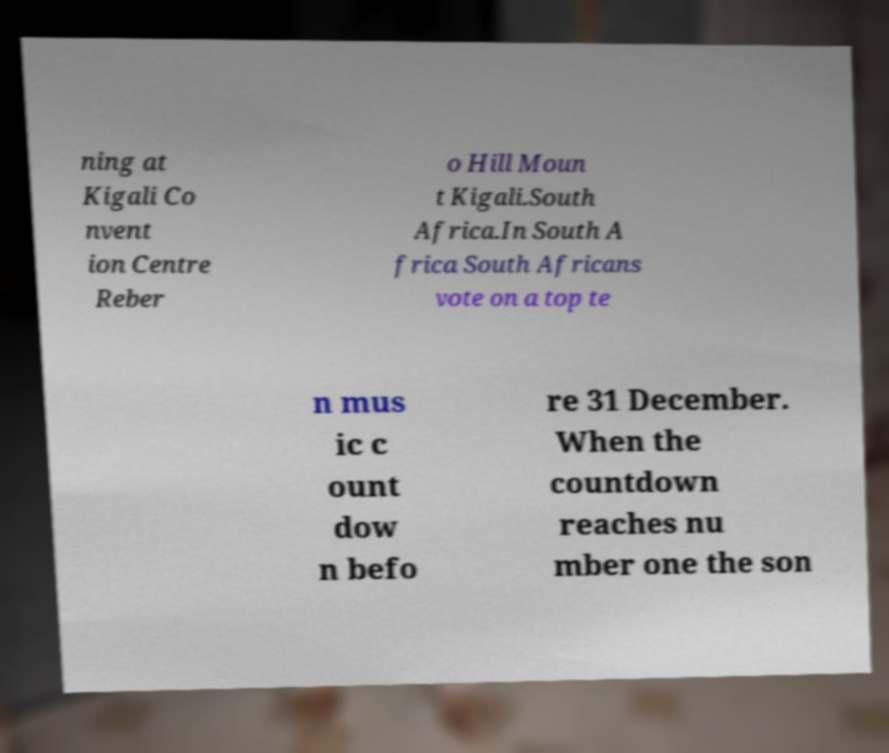Can you accurately transcribe the text from the provided image for me? ning at Kigali Co nvent ion Centre Reber o Hill Moun t Kigali.South Africa.In South A frica South Africans vote on a top te n mus ic c ount dow n befo re 31 December. When the countdown reaches nu mber one the son 